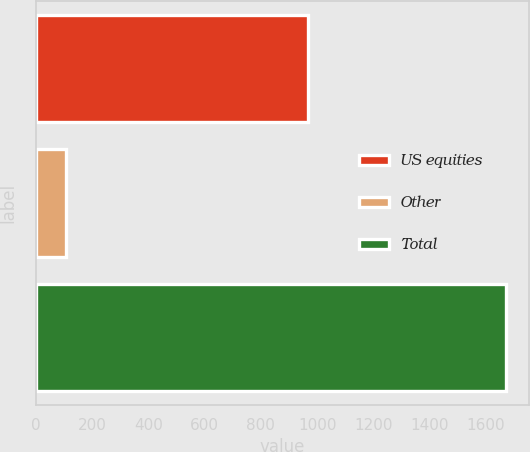<chart> <loc_0><loc_0><loc_500><loc_500><bar_chart><fcel>US equities<fcel>Other<fcel>Total<nl><fcel>968<fcel>107<fcel>1670<nl></chart> 